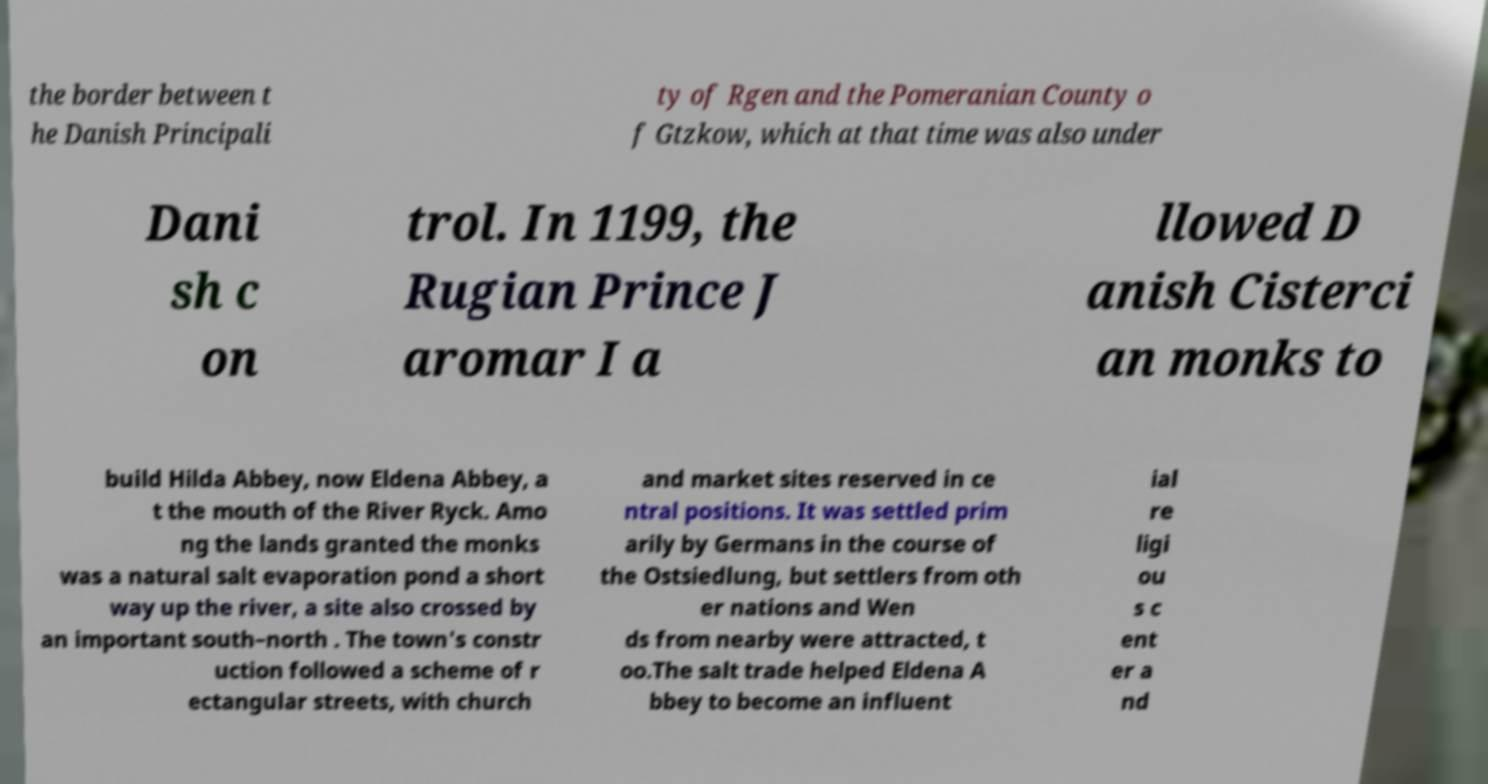What messages or text are displayed in this image? I need them in a readable, typed format. the border between t he Danish Principali ty of Rgen and the Pomeranian County o f Gtzkow, which at that time was also under Dani sh c on trol. In 1199, the Rugian Prince J aromar I a llowed D anish Cisterci an monks to build Hilda Abbey, now Eldena Abbey, a t the mouth of the River Ryck. Amo ng the lands granted the monks was a natural salt evaporation pond a short way up the river, a site also crossed by an important south–north . The town's constr uction followed a scheme of r ectangular streets, with church and market sites reserved in ce ntral positions. It was settled prim arily by Germans in the course of the Ostsiedlung, but settlers from oth er nations and Wen ds from nearby were attracted, t oo.The salt trade helped Eldena A bbey to become an influent ial re ligi ou s c ent er a nd 